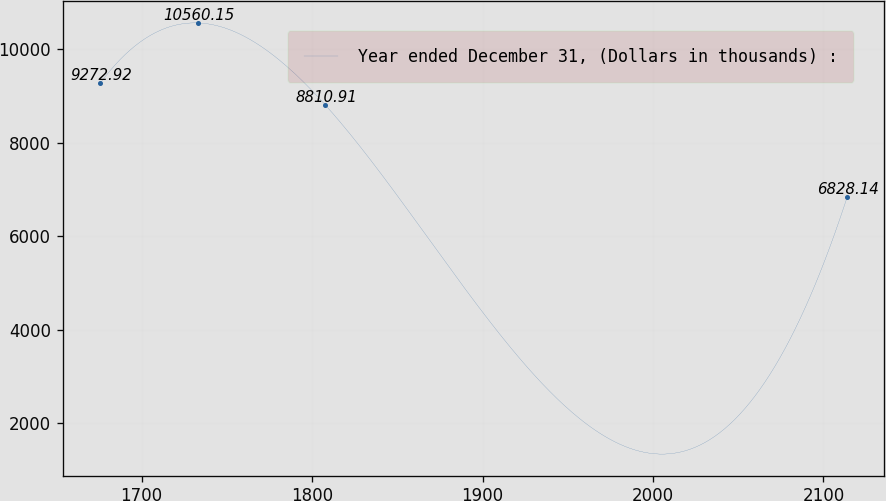Convert chart to OTSL. <chart><loc_0><loc_0><loc_500><loc_500><line_chart><ecel><fcel>Year ended December 31, (Dollars in thousands) :<nl><fcel>1675.7<fcel>9272.92<nl><fcel>1733.2<fcel>10560.1<nl><fcel>1807.64<fcel>8810.91<nl><fcel>2113.87<fcel>6828.14<nl></chart> 